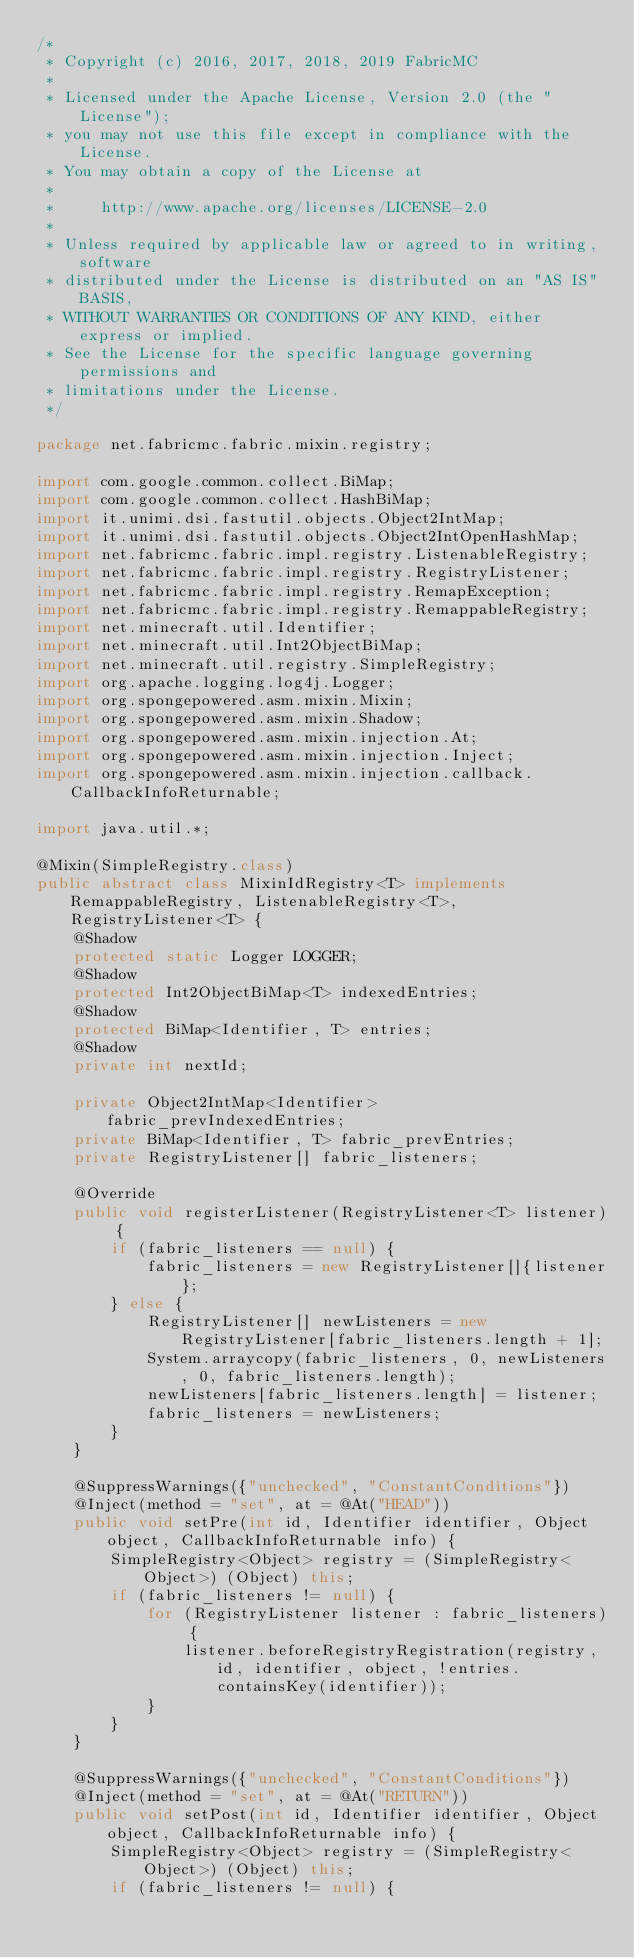Convert code to text. <code><loc_0><loc_0><loc_500><loc_500><_Java_>/*
 * Copyright (c) 2016, 2017, 2018, 2019 FabricMC
 *
 * Licensed under the Apache License, Version 2.0 (the "License");
 * you may not use this file except in compliance with the License.
 * You may obtain a copy of the License at
 *
 *     http://www.apache.org/licenses/LICENSE-2.0
 *
 * Unless required by applicable law or agreed to in writing, software
 * distributed under the License is distributed on an "AS IS" BASIS,
 * WITHOUT WARRANTIES OR CONDITIONS OF ANY KIND, either express or implied.
 * See the License for the specific language governing permissions and
 * limitations under the License.
 */

package net.fabricmc.fabric.mixin.registry;

import com.google.common.collect.BiMap;
import com.google.common.collect.HashBiMap;
import it.unimi.dsi.fastutil.objects.Object2IntMap;
import it.unimi.dsi.fastutil.objects.Object2IntOpenHashMap;
import net.fabricmc.fabric.impl.registry.ListenableRegistry;
import net.fabricmc.fabric.impl.registry.RegistryListener;
import net.fabricmc.fabric.impl.registry.RemapException;
import net.fabricmc.fabric.impl.registry.RemappableRegistry;
import net.minecraft.util.Identifier;
import net.minecraft.util.Int2ObjectBiMap;
import net.minecraft.util.registry.SimpleRegistry;
import org.apache.logging.log4j.Logger;
import org.spongepowered.asm.mixin.Mixin;
import org.spongepowered.asm.mixin.Shadow;
import org.spongepowered.asm.mixin.injection.At;
import org.spongepowered.asm.mixin.injection.Inject;
import org.spongepowered.asm.mixin.injection.callback.CallbackInfoReturnable;

import java.util.*;

@Mixin(SimpleRegistry.class)
public abstract class MixinIdRegistry<T> implements RemappableRegistry, ListenableRegistry<T>, RegistryListener<T> {
	@Shadow
	protected static Logger LOGGER;
	@Shadow
	protected Int2ObjectBiMap<T> indexedEntries;
	@Shadow
	protected BiMap<Identifier, T> entries;
	@Shadow
	private int nextId;

	private Object2IntMap<Identifier> fabric_prevIndexedEntries;
	private BiMap<Identifier, T> fabric_prevEntries;
	private RegistryListener[] fabric_listeners;

	@Override
	public void registerListener(RegistryListener<T> listener) {
		if (fabric_listeners == null) {
			fabric_listeners = new RegistryListener[]{listener};
		} else {
			RegistryListener[] newListeners = new RegistryListener[fabric_listeners.length + 1];
			System.arraycopy(fabric_listeners, 0, newListeners, 0, fabric_listeners.length);
			newListeners[fabric_listeners.length] = listener;
			fabric_listeners = newListeners;
		}
	}

	@SuppressWarnings({"unchecked", "ConstantConditions"})
	@Inject(method = "set", at = @At("HEAD"))
	public void setPre(int id, Identifier identifier, Object object, CallbackInfoReturnable info) {
		SimpleRegistry<Object> registry = (SimpleRegistry<Object>) (Object) this;
		if (fabric_listeners != null) {
			for (RegistryListener listener : fabric_listeners) {
				listener.beforeRegistryRegistration(registry, id, identifier, object, !entries.containsKey(identifier));
			}
		}
	}

	@SuppressWarnings({"unchecked", "ConstantConditions"})
	@Inject(method = "set", at = @At("RETURN"))
	public void setPost(int id, Identifier identifier, Object object, CallbackInfoReturnable info) {
		SimpleRegistry<Object> registry = (SimpleRegistry<Object>) (Object) this;
		if (fabric_listeners != null) {</code> 